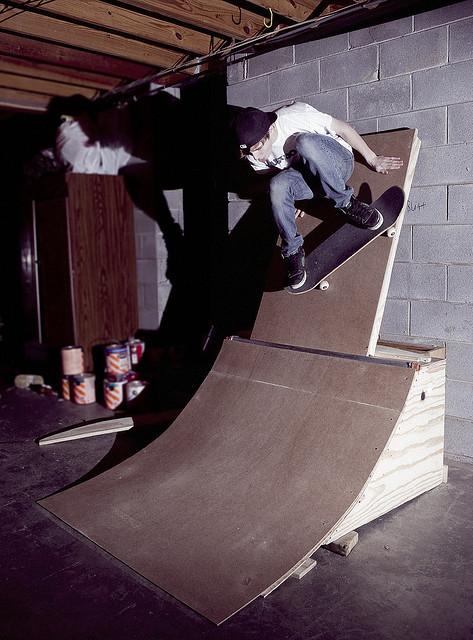What is the ceiling made of?
Short answer required. Wood. Do you think that ramp is made out of concrete or plastic?
Answer briefly. Wood. Where is the shadow?
Give a very brief answer. On wall. Does this slope look solidly built?
Be succinct. No. What is the apparatus the skater is on called?
Concise answer only. Ramp. Is this a skate park?
Write a very short answer. No. 